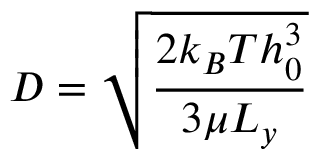<formula> <loc_0><loc_0><loc_500><loc_500>D = \sqrt { \frac { 2 k _ { B } T h _ { 0 } ^ { 3 } } { 3 \mu L _ { y } } }</formula> 